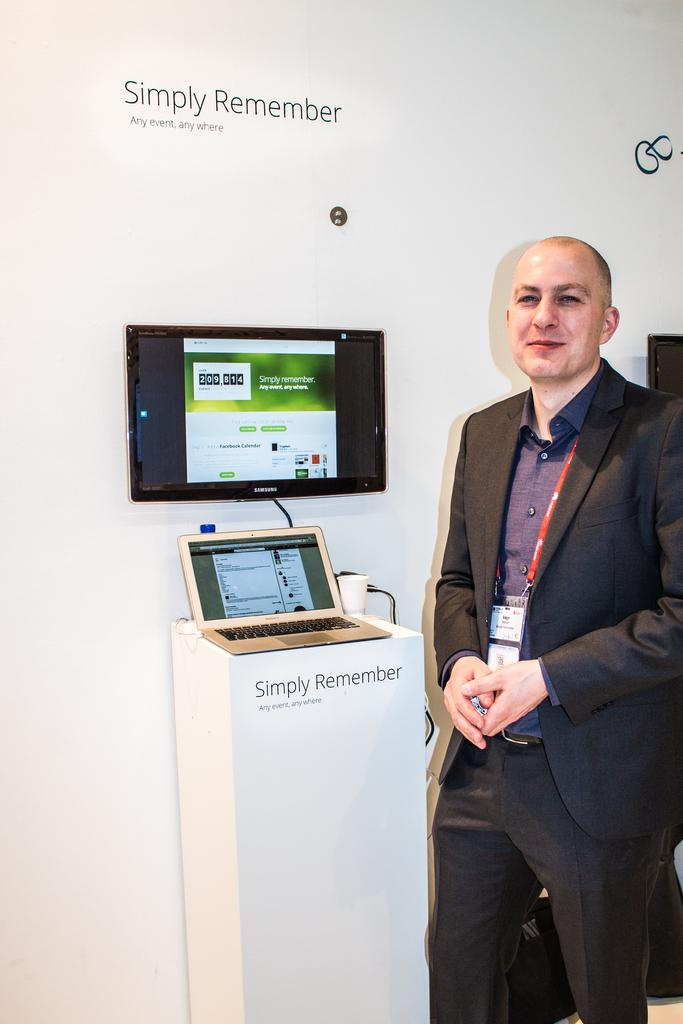Who is present in the image? There is a man in the image. What is the man doing in the image? The man is standing and smiling. What is the man wearing in the image? The man is wearing a suit. What objects can be seen on the left side of the image? There is a laptop and a monitor on the left side of the image. What else can be seen in the image? There is some text visible in the image. What type of baseball bat is the man holding in the image? There is no baseball bat present in the image; the man is holding a smile and wearing a suit. What does the voice of the dinosaur sound like in the image? There are no dinosaurs or voices present in the image; it features a man standing and smiling, wearing a suit, with a laptop and monitor on the left side, and some text visible. 